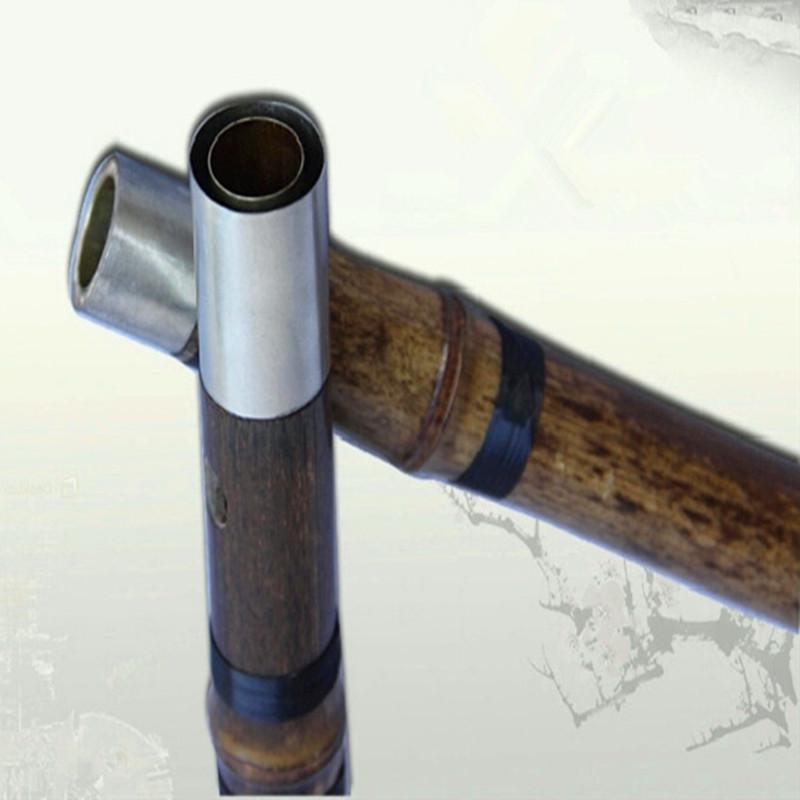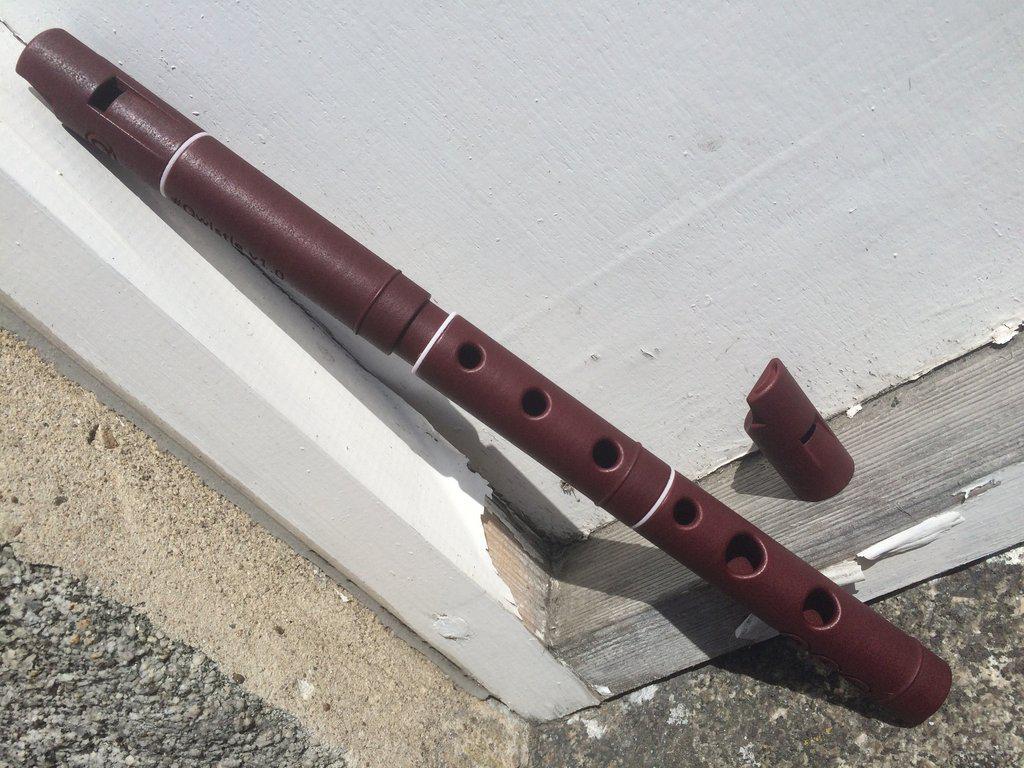The first image is the image on the left, the second image is the image on the right. Examine the images to the left and right. Is the description "One image contains a single flute, and the other image shows two silver metal ends that overlap." accurate? Answer yes or no. Yes. The first image is the image on the left, the second image is the image on the right. For the images displayed, is the sentence "There is a single flute in the left image." factually correct? Answer yes or no. No. 